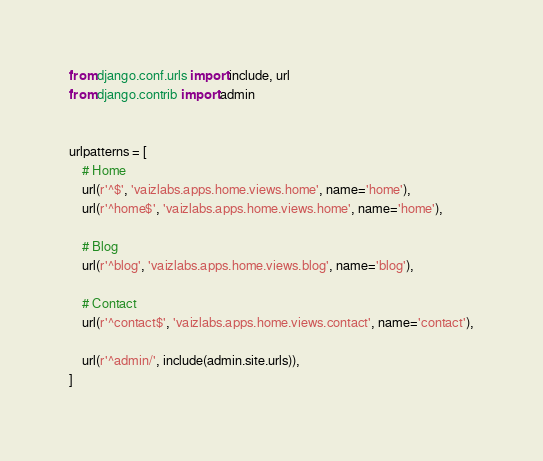Convert code to text. <code><loc_0><loc_0><loc_500><loc_500><_Python_>from django.conf.urls import include, url
from django.contrib import admin


urlpatterns = [
    # Home
    url(r'^$', 'vaizlabs.apps.home.views.home', name='home'),
    url(r'^home$', 'vaizlabs.apps.home.views.home', name='home'),
      
    # Blog 
    url(r'^blog', 'vaizlabs.apps.home.views.blog', name='blog'),

    # Contact 
    url(r'^contact$', 'vaizlabs.apps.home.views.contact', name='contact'),

    url(r'^admin/', include(admin.site.urls)),
]
</code> 